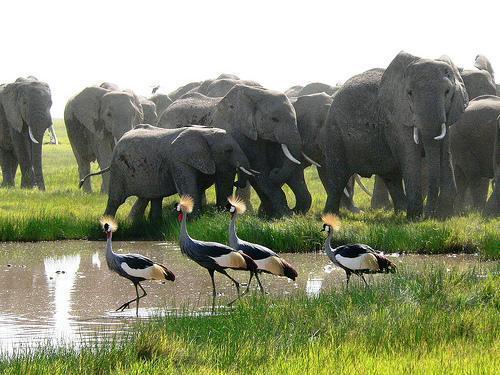How many baby elephants are there?
Give a very brief answer. 1. How many peacocks?
Give a very brief answer. 4. 